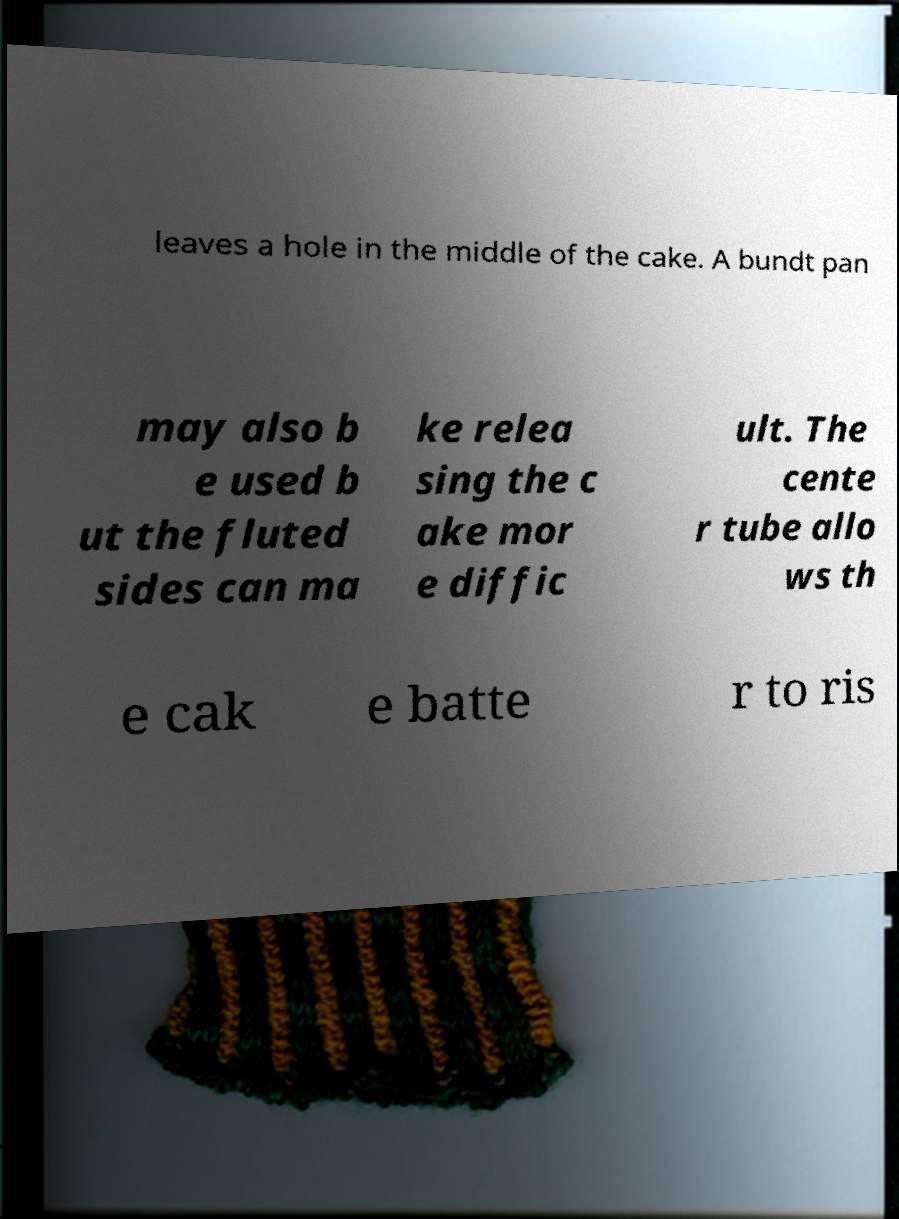Can you read and provide the text displayed in the image?This photo seems to have some interesting text. Can you extract and type it out for me? leaves a hole in the middle of the cake. A bundt pan may also b e used b ut the fluted sides can ma ke relea sing the c ake mor e diffic ult. The cente r tube allo ws th e cak e batte r to ris 